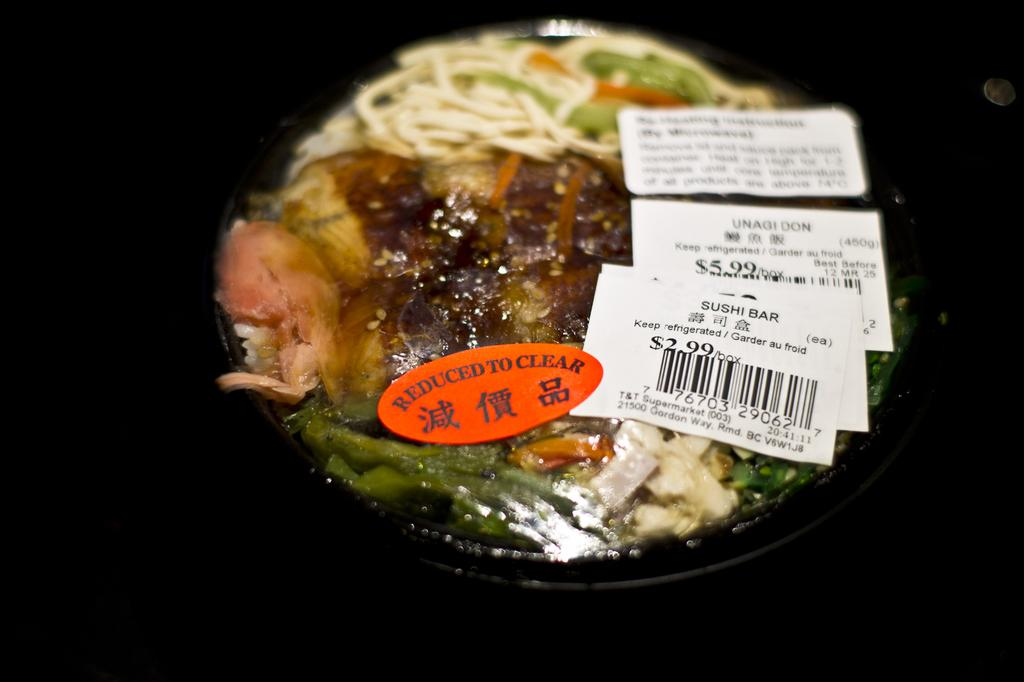What is the main subject of the image? There is a food item in the image. How is the food item stored or contained? The food item is kept in a container. Are there any additional details about the food item or its surroundings? There are price tags in the image. Can you describe the overall appearance of the image? The background of the image is dark. What type of cast can be seen on the food item in the image? There is no cast present on the food item in the image. How many tickets are visible in the image? There are no tickets visible in the image. 